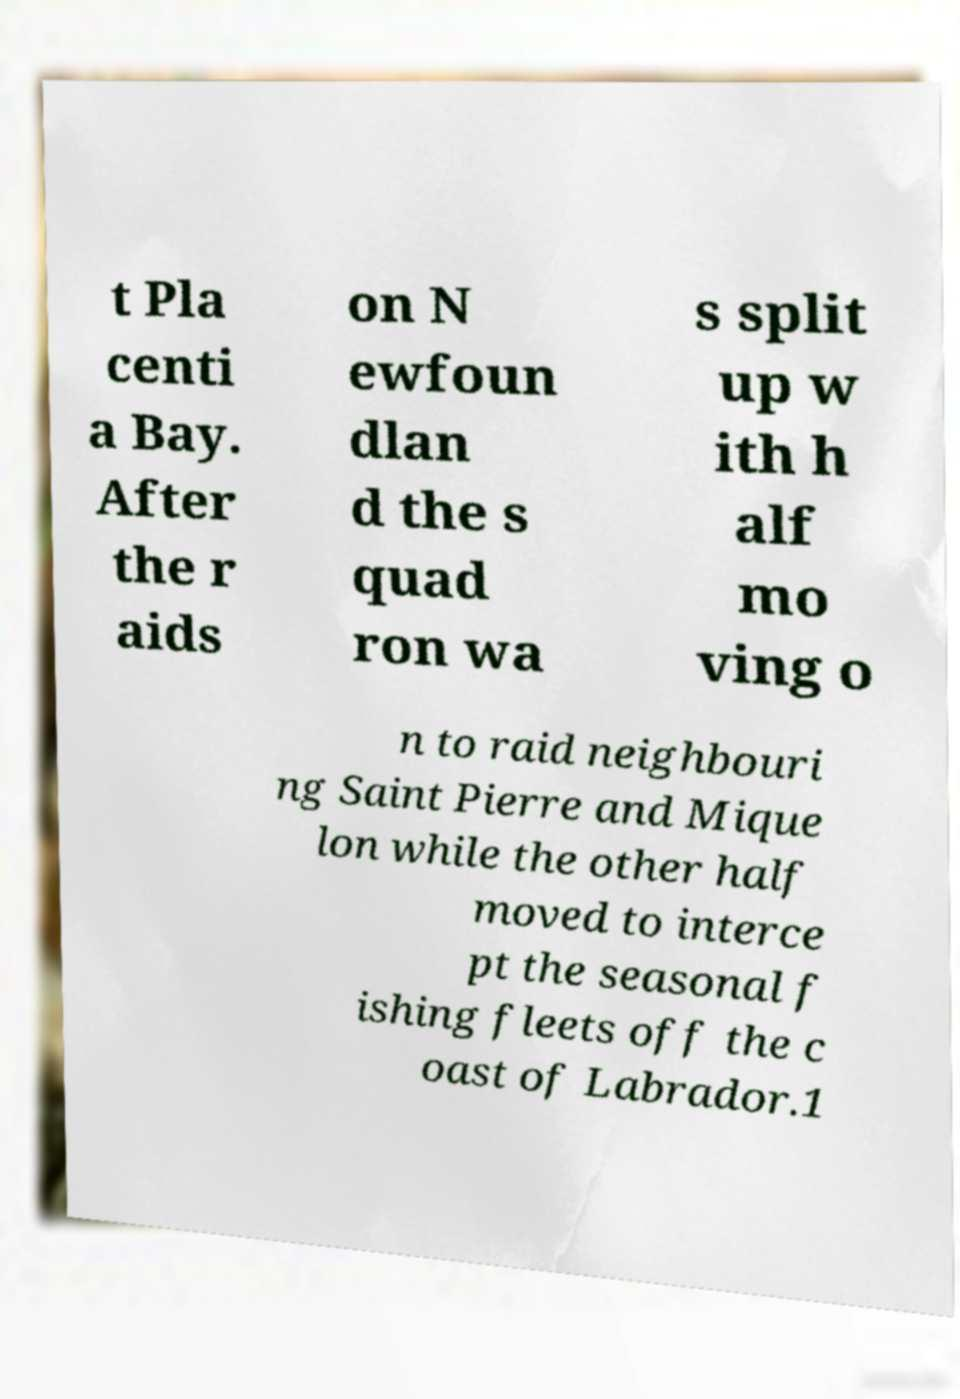Could you assist in decoding the text presented in this image and type it out clearly? t Pla centi a Bay. After the r aids on N ewfoun dlan d the s quad ron wa s split up w ith h alf mo ving o n to raid neighbouri ng Saint Pierre and Mique lon while the other half moved to interce pt the seasonal f ishing fleets off the c oast of Labrador.1 